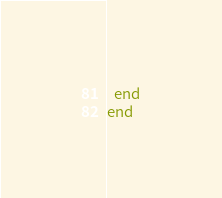<code> <loc_0><loc_0><loc_500><loc_500><_Ruby_>  end
end
</code> 